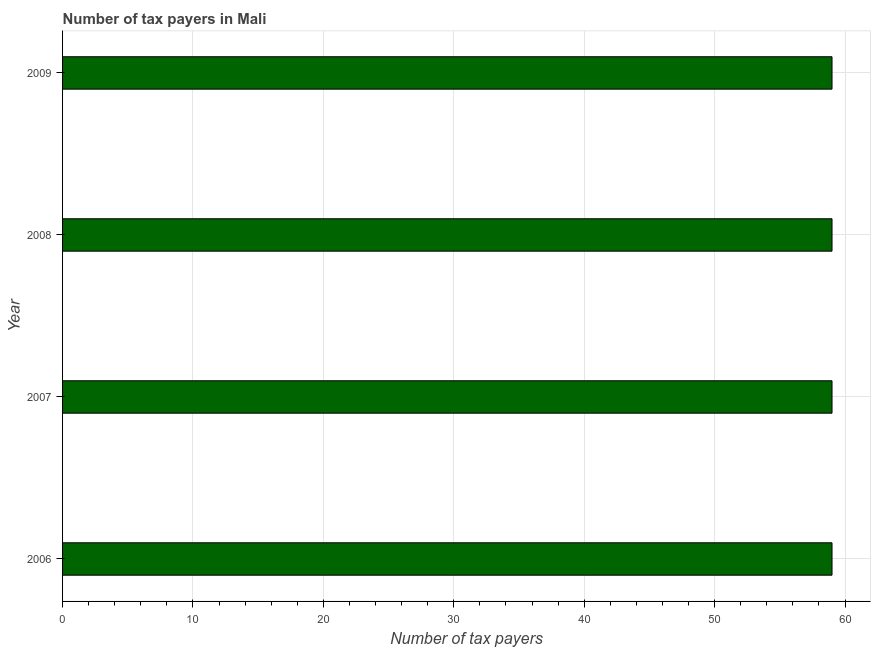Does the graph contain any zero values?
Make the answer very short. No. Does the graph contain grids?
Offer a very short reply. Yes. What is the title of the graph?
Your answer should be compact. Number of tax payers in Mali. What is the label or title of the X-axis?
Your response must be concise. Number of tax payers. In which year was the number of tax payers maximum?
Provide a succinct answer. 2006. What is the sum of the number of tax payers?
Your response must be concise. 236. What is the difference between the number of tax payers in 2007 and 2009?
Provide a short and direct response. 0. What is the average number of tax payers per year?
Your response must be concise. 59. What is the median number of tax payers?
Your answer should be compact. 59. What is the difference between the highest and the second highest number of tax payers?
Provide a short and direct response. 0. Are all the bars in the graph horizontal?
Provide a short and direct response. Yes. What is the difference between two consecutive major ticks on the X-axis?
Make the answer very short. 10. What is the Number of tax payers in 2006?
Make the answer very short. 59. What is the Number of tax payers in 2007?
Keep it short and to the point. 59. What is the Number of tax payers of 2008?
Ensure brevity in your answer.  59. What is the difference between the Number of tax payers in 2006 and 2008?
Your response must be concise. 0. What is the difference between the Number of tax payers in 2006 and 2009?
Keep it short and to the point. 0. What is the difference between the Number of tax payers in 2007 and 2008?
Offer a very short reply. 0. What is the difference between the Number of tax payers in 2007 and 2009?
Offer a terse response. 0. What is the difference between the Number of tax payers in 2008 and 2009?
Provide a succinct answer. 0. What is the ratio of the Number of tax payers in 2006 to that in 2007?
Keep it short and to the point. 1. What is the ratio of the Number of tax payers in 2006 to that in 2009?
Ensure brevity in your answer.  1. What is the ratio of the Number of tax payers in 2007 to that in 2009?
Provide a short and direct response. 1. What is the ratio of the Number of tax payers in 2008 to that in 2009?
Keep it short and to the point. 1. 